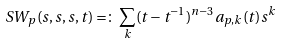Convert formula to latex. <formula><loc_0><loc_0><loc_500><loc_500>S W _ { p } ( s , s , s , t ) = \colon \sum _ { k } ( t - t ^ { - 1 } ) ^ { n - 3 } a _ { p , k } ( t ) s ^ { k }</formula> 